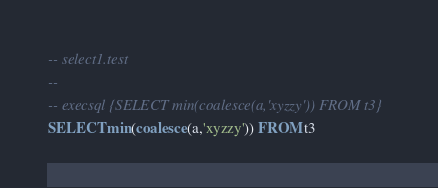<code> <loc_0><loc_0><loc_500><loc_500><_SQL_>-- select1.test
-- 
-- execsql {SELECT min(coalesce(a,'xyzzy')) FROM t3}
SELECT min(coalesce(a,'xyzzy')) FROM t3</code> 